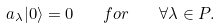<formula> <loc_0><loc_0><loc_500><loc_500>a _ { \lambda } | 0 \rangle = 0 \quad f o r \quad \forall \lambda \in P .</formula> 